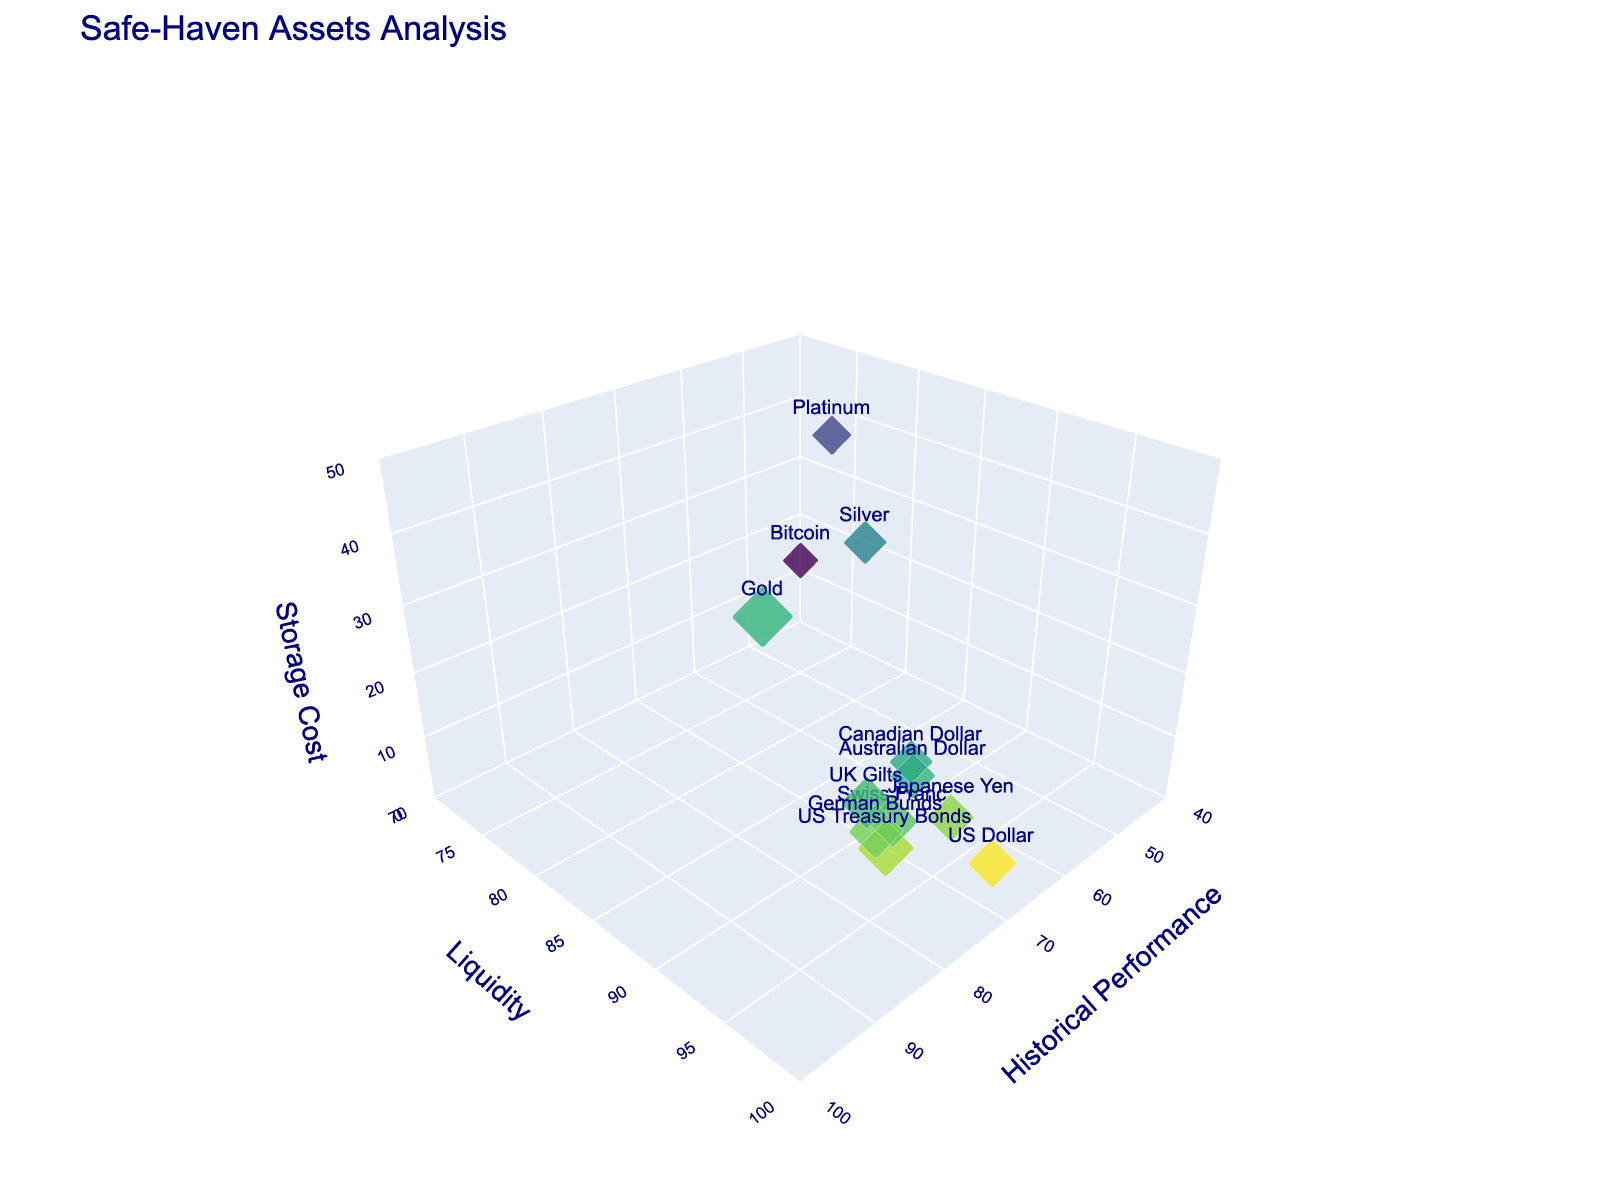What is the title of the plot? The title is shown at the top of the plot, providing a summary of what the chart represents.
Answer: Safe-Haven Assets Analysis What are the x-axis, y-axis, and z-axis titles in the plot? The axis titles are shown along their respective axes and define what each axis measures. The x-axis title is 'Historical Performance', the y-axis title is 'Liquidity', and the z-axis title is 'Storage Cost'.
Answer: Historical Performance, Liquidity, Storage Cost How many data points are there in the plot? Each marker on the plot represents a data point. By counting these, one can determine the total number. There are 12 markers on the plot.
Answer: 12 Which asset has the highest liquidity? The asset with the highest value on the y-axis has the highest liquidity. US Dollar is at 98 on the y-axis, which is the highest value for liquidity.
Answer: US Dollar Which asset has the lowest storage cost? The asset with the lowest position on the z-axis has the lowest storage cost. Both Swiss Franc and Japanese Yen are at 5 on the z-axis, which are the lowest values for storage cost.
Answer: Swiss Franc, Japanese Yen Compare the historical performance of Gold and Bitcoin. To compare, look at the x-axis values for Gold and Bitcoin. Gold has a historical performance of 85, while Bitcoin has a historical performance of 50. Gold's historical performance is significantly higher than Bitcoin's.
Answer: Gold has higher historical performance What is the average storage cost of Gold and Silver? Average calculation requires adding the storage costs of Gold (40) and Silver (35), then dividing by 2. (40+35)/2 = 37.5
Answer: 37.5 Which asset has the largest bubble size in the plot? Bubble size is proportional to 'Historical Performance'. Gold has the largest bubble size since it has the highest historical performance value of 85.
Answer: Gold How does the liquidity of US Treasury Bonds compare to German Bunds? Comparing the y-axis values, US Treasury Bonds have a liquidity of 95, while German Bunds have a liquidity of 93. US Treasury Bonds have higher liquidity.
Answer: US Treasury Bonds have higher liquidity What's the sum of storage costs for Canadian Dollar and Australian Dollar? Sum of storage costs requires adding the respective z-axis values for Canadian Dollar (5) and Australian Dollar (5). 5 + 5 = 10
Answer: 10 